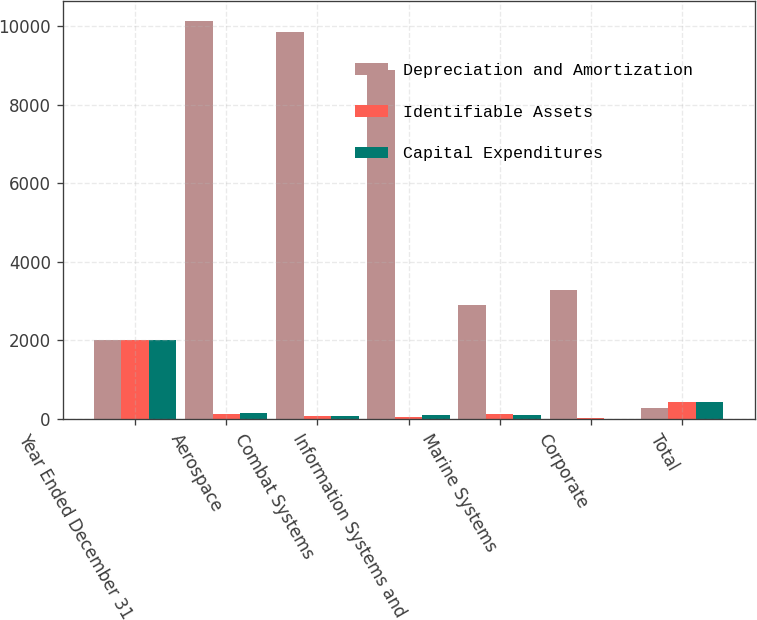Convert chart. <chart><loc_0><loc_0><loc_500><loc_500><stacked_bar_chart><ecel><fcel>Year Ended December 31<fcel>Aerospace<fcel>Combat Systems<fcel>Information Systems and<fcel>Marine Systems<fcel>Corporate<fcel>Total<nl><fcel>Depreciation and Amortization<fcel>2017<fcel>10126<fcel>9846<fcel>8877<fcel>2906<fcel>3291<fcel>287.5<nl><fcel>Identifiable Assets<fcel>2017<fcel>132<fcel>84<fcel>63<fcel>123<fcel>26<fcel>428<nl><fcel>Capital Expenditures<fcel>2017<fcel>147<fcel>86<fcel>92<fcel>109<fcel>7<fcel>441<nl></chart> 